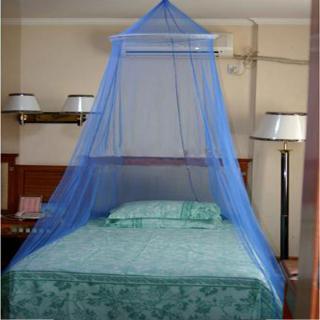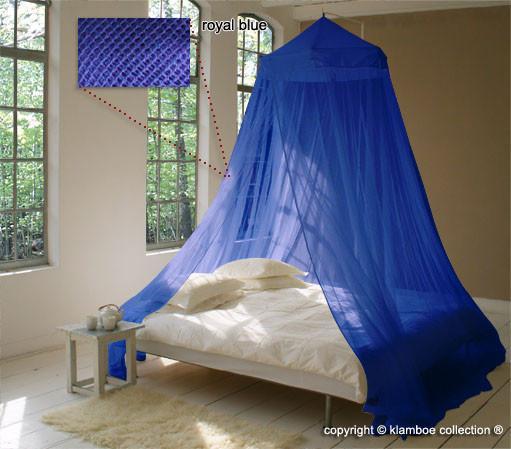The first image is the image on the left, the second image is the image on the right. Assess this claim about the two images: "The bed draperies in each image are similar in color and suspended from a circular framework over the bed.". Correct or not? Answer yes or no. Yes. The first image is the image on the left, the second image is the image on the right. Considering the images on both sides, is "All the nets are blue." valid? Answer yes or no. Yes. 